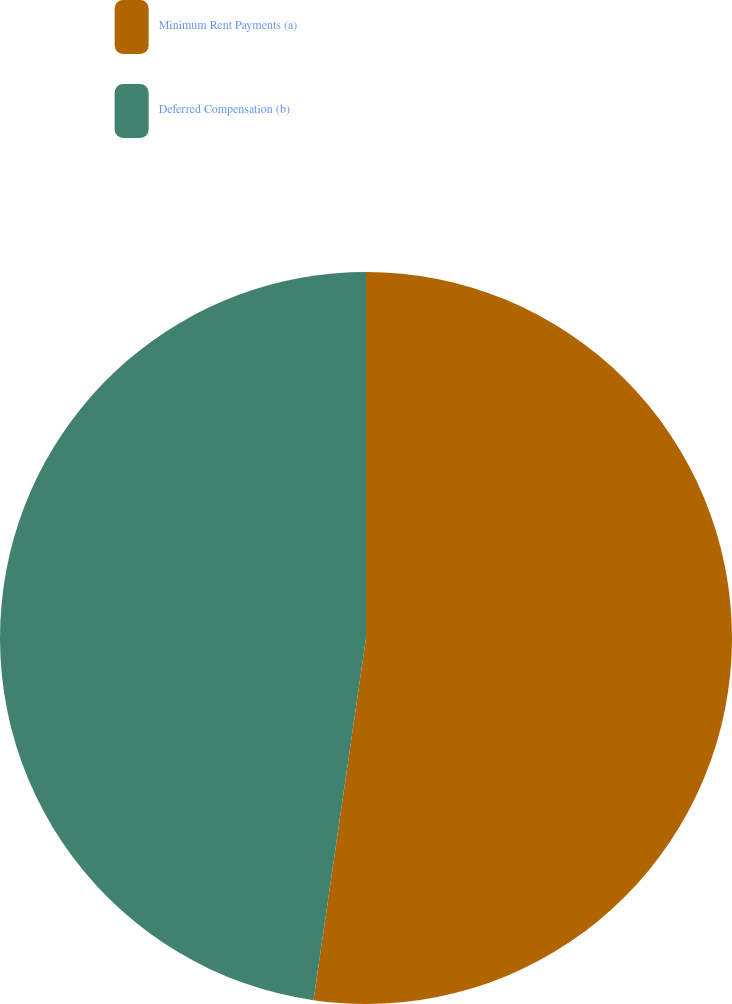Convert chart. <chart><loc_0><loc_0><loc_500><loc_500><pie_chart><fcel>Minimum Rent Payments (a)<fcel>Deferred Compensation (b)<nl><fcel>52.29%<fcel>47.71%<nl></chart> 